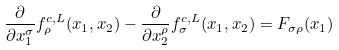<formula> <loc_0><loc_0><loc_500><loc_500>\frac { \partial } { \partial x _ { 1 } ^ { \sigma } } f _ { \rho } ^ { c , L } ( x _ { 1 } , x _ { 2 } ) - \frac { \partial } { \partial x _ { 2 } ^ { \rho } } f _ { \sigma } ^ { c , L } ( x _ { 1 } , x _ { 2 } ) = F _ { \sigma \rho } ( x _ { 1 } )</formula> 